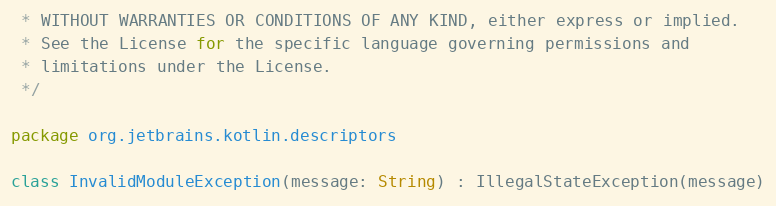Convert code to text. <code><loc_0><loc_0><loc_500><loc_500><_Kotlin_> * WITHOUT WARRANTIES OR CONDITIONS OF ANY KIND, either express or implied.
 * See the License for the specific language governing permissions and
 * limitations under the License.
 */

package org.jetbrains.kotlin.descriptors

class InvalidModuleException(message: String) : IllegalStateException(message)</code> 